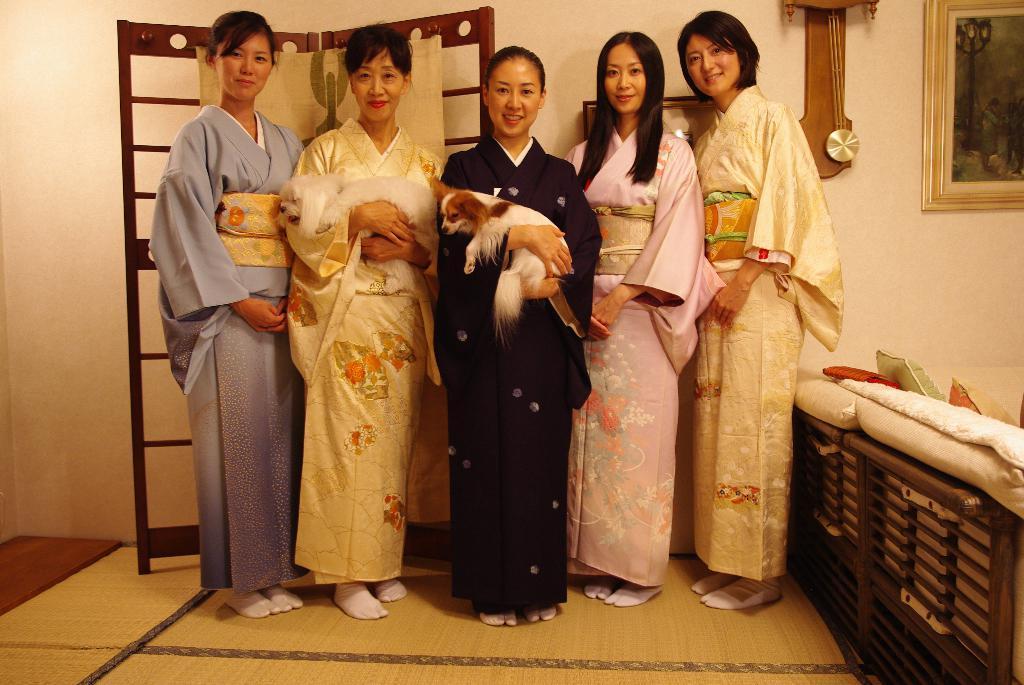Please provide a concise description of this image. In this image we can see five women standing in a room, two of them are holding dogs in their hands, there is a stand at the back, a picture frame and clock attached to the wall and there is a couch on the right side. 